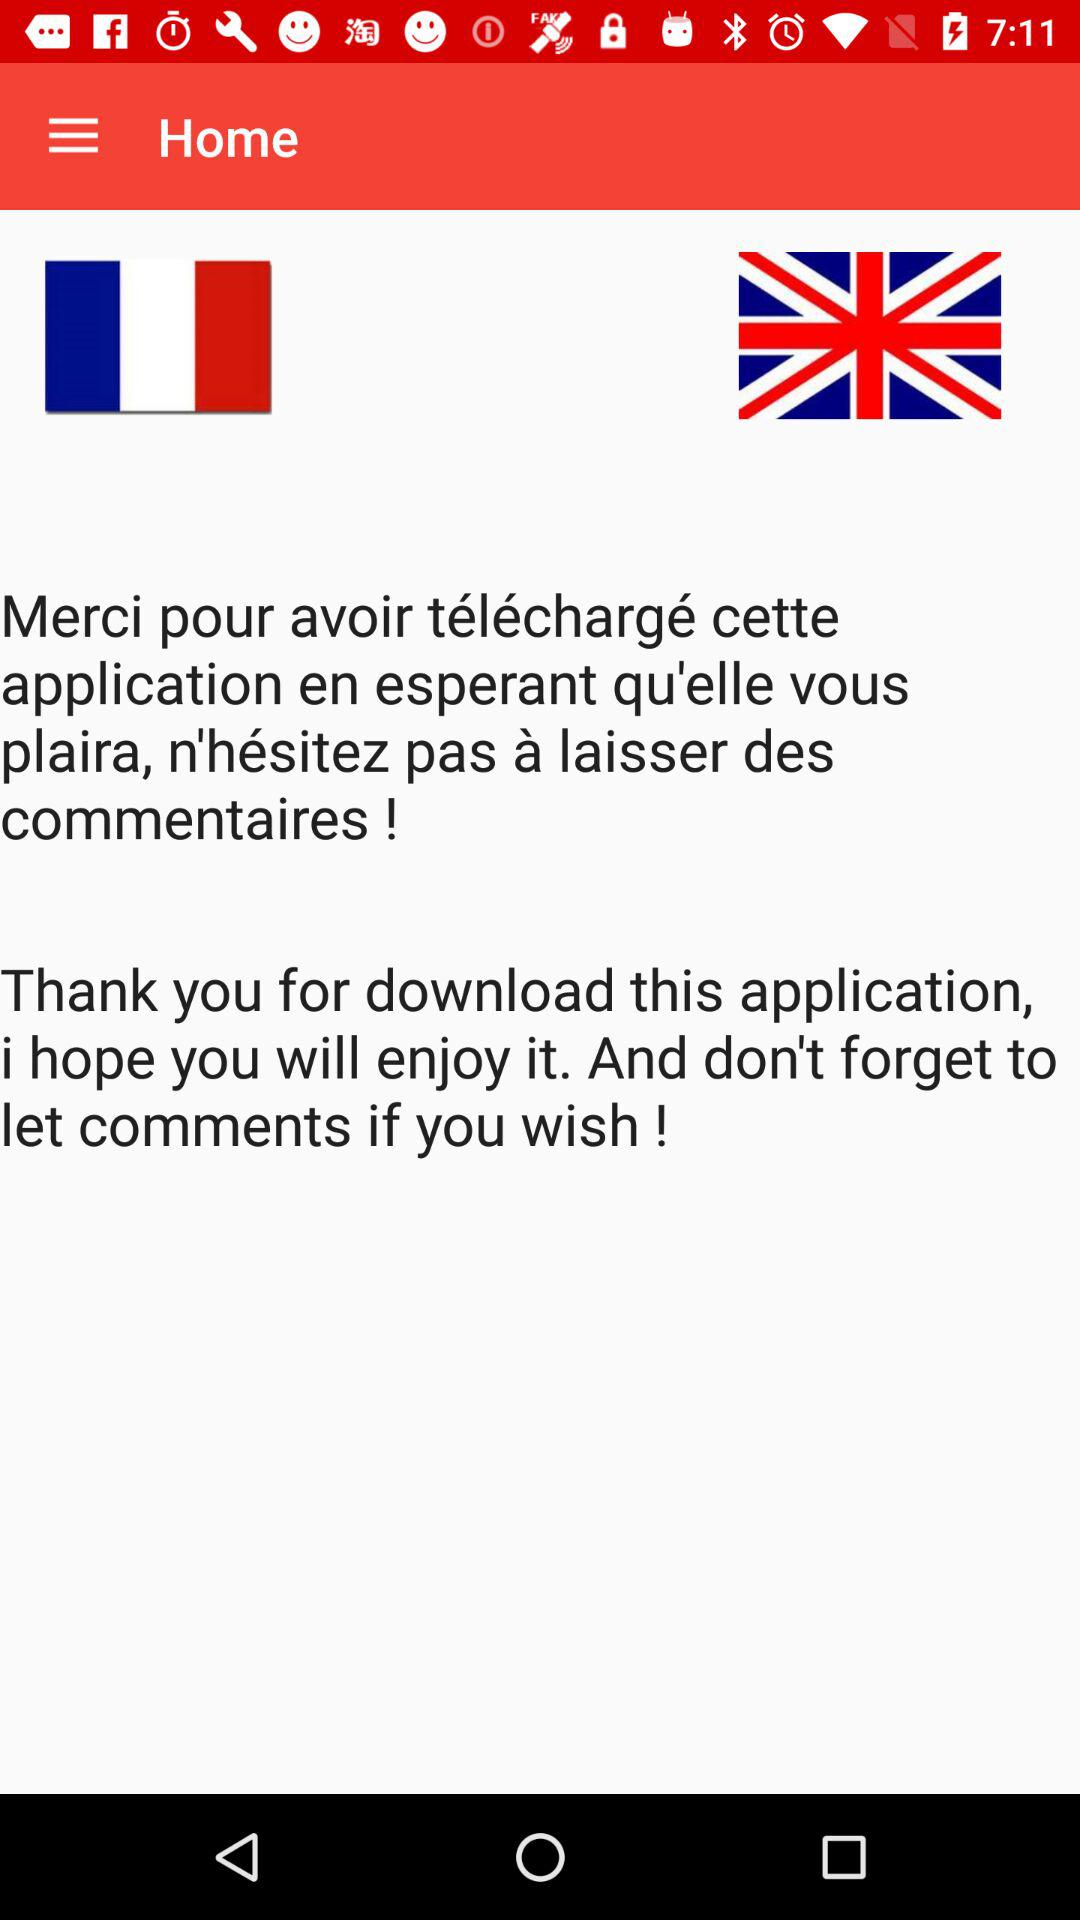How many languages are available?
Answer the question using a single word or phrase. 2 